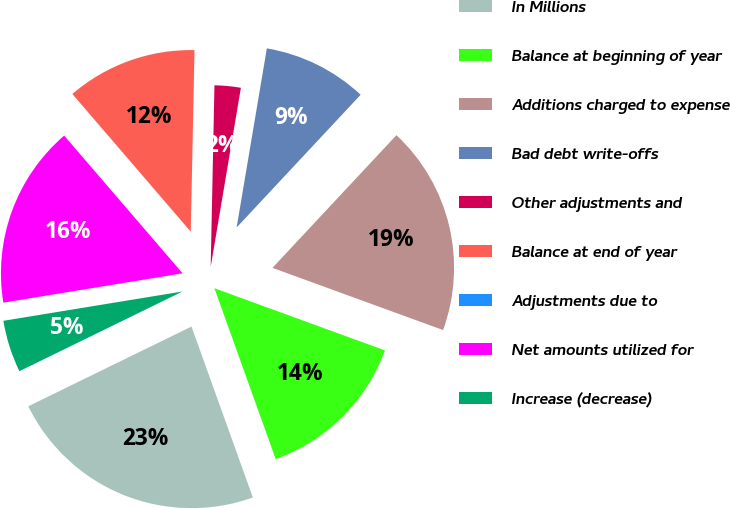Convert chart to OTSL. <chart><loc_0><loc_0><loc_500><loc_500><pie_chart><fcel>In Millions<fcel>Balance at beginning of year<fcel>Additions charged to expense<fcel>Bad debt write-offs<fcel>Other adjustments and<fcel>Balance at end of year<fcel>Adjustments due to<fcel>Net amounts utilized for<fcel>Increase (decrease)<nl><fcel>23.25%<fcel>13.95%<fcel>18.6%<fcel>9.3%<fcel>2.33%<fcel>11.63%<fcel>0.0%<fcel>16.28%<fcel>4.65%<nl></chart> 